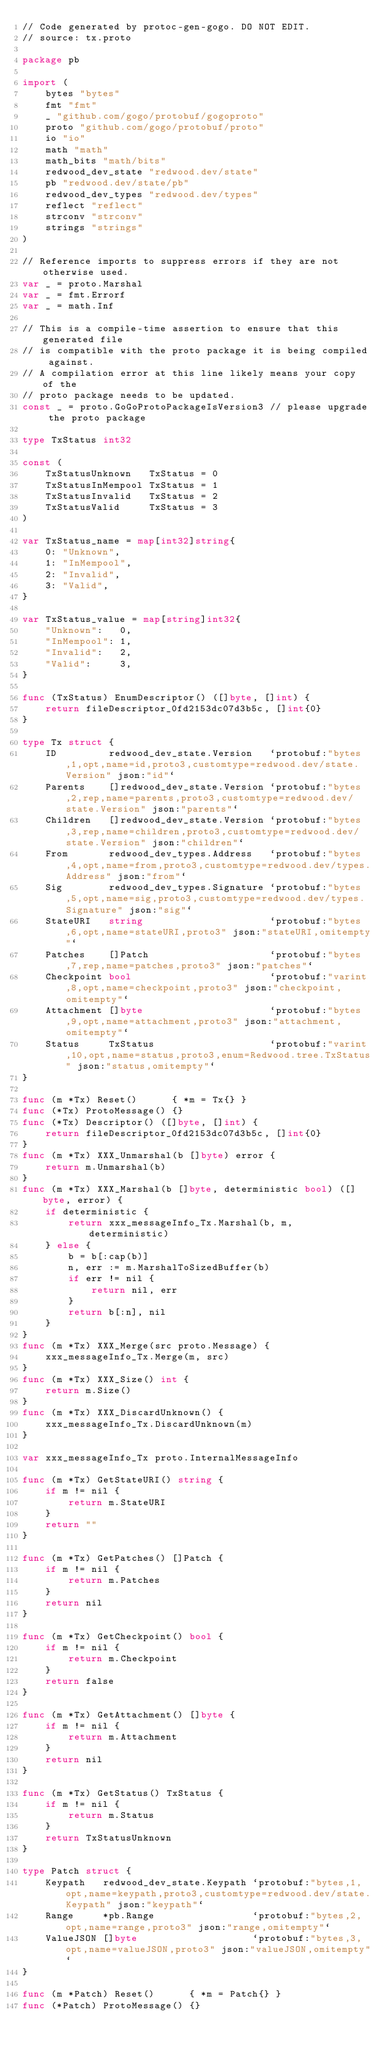<code> <loc_0><loc_0><loc_500><loc_500><_Go_>// Code generated by protoc-gen-gogo. DO NOT EDIT.
// source: tx.proto

package pb

import (
	bytes "bytes"
	fmt "fmt"
	_ "github.com/gogo/protobuf/gogoproto"
	proto "github.com/gogo/protobuf/proto"
	io "io"
	math "math"
	math_bits "math/bits"
	redwood_dev_state "redwood.dev/state"
	pb "redwood.dev/state/pb"
	redwood_dev_types "redwood.dev/types"
	reflect "reflect"
	strconv "strconv"
	strings "strings"
)

// Reference imports to suppress errors if they are not otherwise used.
var _ = proto.Marshal
var _ = fmt.Errorf
var _ = math.Inf

// This is a compile-time assertion to ensure that this generated file
// is compatible with the proto package it is being compiled against.
// A compilation error at this line likely means your copy of the
// proto package needs to be updated.
const _ = proto.GoGoProtoPackageIsVersion3 // please upgrade the proto package

type TxStatus int32

const (
	TxStatusUnknown   TxStatus = 0
	TxStatusInMempool TxStatus = 1
	TxStatusInvalid   TxStatus = 2
	TxStatusValid     TxStatus = 3
)

var TxStatus_name = map[int32]string{
	0: "Unknown",
	1: "InMempool",
	2: "Invalid",
	3: "Valid",
}

var TxStatus_value = map[string]int32{
	"Unknown":   0,
	"InMempool": 1,
	"Invalid":   2,
	"Valid":     3,
}

func (TxStatus) EnumDescriptor() ([]byte, []int) {
	return fileDescriptor_0fd2153dc07d3b5c, []int{0}
}

type Tx struct {
	ID         redwood_dev_state.Version   `protobuf:"bytes,1,opt,name=id,proto3,customtype=redwood.dev/state.Version" json:"id"`
	Parents    []redwood_dev_state.Version `protobuf:"bytes,2,rep,name=parents,proto3,customtype=redwood.dev/state.Version" json:"parents"`
	Children   []redwood_dev_state.Version `protobuf:"bytes,3,rep,name=children,proto3,customtype=redwood.dev/state.Version" json:"children"`
	From       redwood_dev_types.Address   `protobuf:"bytes,4,opt,name=from,proto3,customtype=redwood.dev/types.Address" json:"from"`
	Sig        redwood_dev_types.Signature `protobuf:"bytes,5,opt,name=sig,proto3,customtype=redwood.dev/types.Signature" json:"sig"`
	StateURI   string                      `protobuf:"bytes,6,opt,name=stateURI,proto3" json:"stateURI,omitempty"`
	Patches    []Patch                     `protobuf:"bytes,7,rep,name=patches,proto3" json:"patches"`
	Checkpoint bool                        `protobuf:"varint,8,opt,name=checkpoint,proto3" json:"checkpoint,omitempty"`
	Attachment []byte                      `protobuf:"bytes,9,opt,name=attachment,proto3" json:"attachment,omitempty"`
	Status     TxStatus                    `protobuf:"varint,10,opt,name=status,proto3,enum=Redwood.tree.TxStatus" json:"status,omitempty"`
}

func (m *Tx) Reset()      { *m = Tx{} }
func (*Tx) ProtoMessage() {}
func (*Tx) Descriptor() ([]byte, []int) {
	return fileDescriptor_0fd2153dc07d3b5c, []int{0}
}
func (m *Tx) XXX_Unmarshal(b []byte) error {
	return m.Unmarshal(b)
}
func (m *Tx) XXX_Marshal(b []byte, deterministic bool) ([]byte, error) {
	if deterministic {
		return xxx_messageInfo_Tx.Marshal(b, m, deterministic)
	} else {
		b = b[:cap(b)]
		n, err := m.MarshalToSizedBuffer(b)
		if err != nil {
			return nil, err
		}
		return b[:n], nil
	}
}
func (m *Tx) XXX_Merge(src proto.Message) {
	xxx_messageInfo_Tx.Merge(m, src)
}
func (m *Tx) XXX_Size() int {
	return m.Size()
}
func (m *Tx) XXX_DiscardUnknown() {
	xxx_messageInfo_Tx.DiscardUnknown(m)
}

var xxx_messageInfo_Tx proto.InternalMessageInfo

func (m *Tx) GetStateURI() string {
	if m != nil {
		return m.StateURI
	}
	return ""
}

func (m *Tx) GetPatches() []Patch {
	if m != nil {
		return m.Patches
	}
	return nil
}

func (m *Tx) GetCheckpoint() bool {
	if m != nil {
		return m.Checkpoint
	}
	return false
}

func (m *Tx) GetAttachment() []byte {
	if m != nil {
		return m.Attachment
	}
	return nil
}

func (m *Tx) GetStatus() TxStatus {
	if m != nil {
		return m.Status
	}
	return TxStatusUnknown
}

type Patch struct {
	Keypath   redwood_dev_state.Keypath `protobuf:"bytes,1,opt,name=keypath,proto3,customtype=redwood.dev/state.Keypath" json:"keypath"`
	Range     *pb.Range                 `protobuf:"bytes,2,opt,name=range,proto3" json:"range,omitempty"`
	ValueJSON []byte                    `protobuf:"bytes,3,opt,name=valueJSON,proto3" json:"valueJSON,omitempty"`
}

func (m *Patch) Reset()      { *m = Patch{} }
func (*Patch) ProtoMessage() {}</code> 